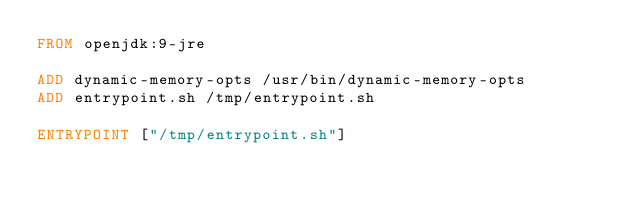<code> <loc_0><loc_0><loc_500><loc_500><_Dockerfile_>FROM openjdk:9-jre

ADD dynamic-memory-opts /usr/bin/dynamic-memory-opts
ADD entrypoint.sh /tmp/entrypoint.sh

ENTRYPOINT ["/tmp/entrypoint.sh"]
</code> 